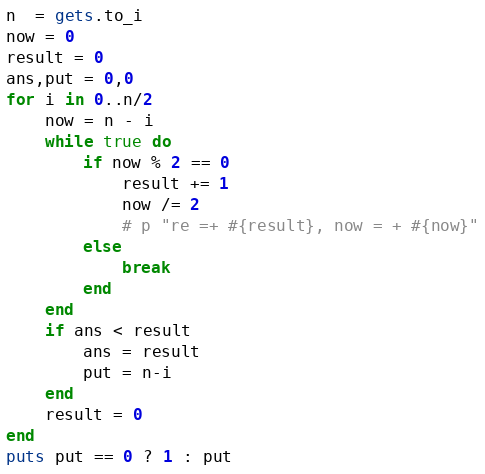Convert code to text. <code><loc_0><loc_0><loc_500><loc_500><_Ruby_>n  = gets.to_i
now = 0
result = 0
ans,put = 0,0
for i in 0..n/2
	now = n - i
	while true do
		if now % 2 == 0
			result += 1
			now /= 2
			# p "re =+ #{result}, now = + #{now}"
		else
			break
		end
	end
	if ans < result
		ans = result
		put = n-i
	end
	result = 0
end
puts put == 0 ? 1 : put</code> 